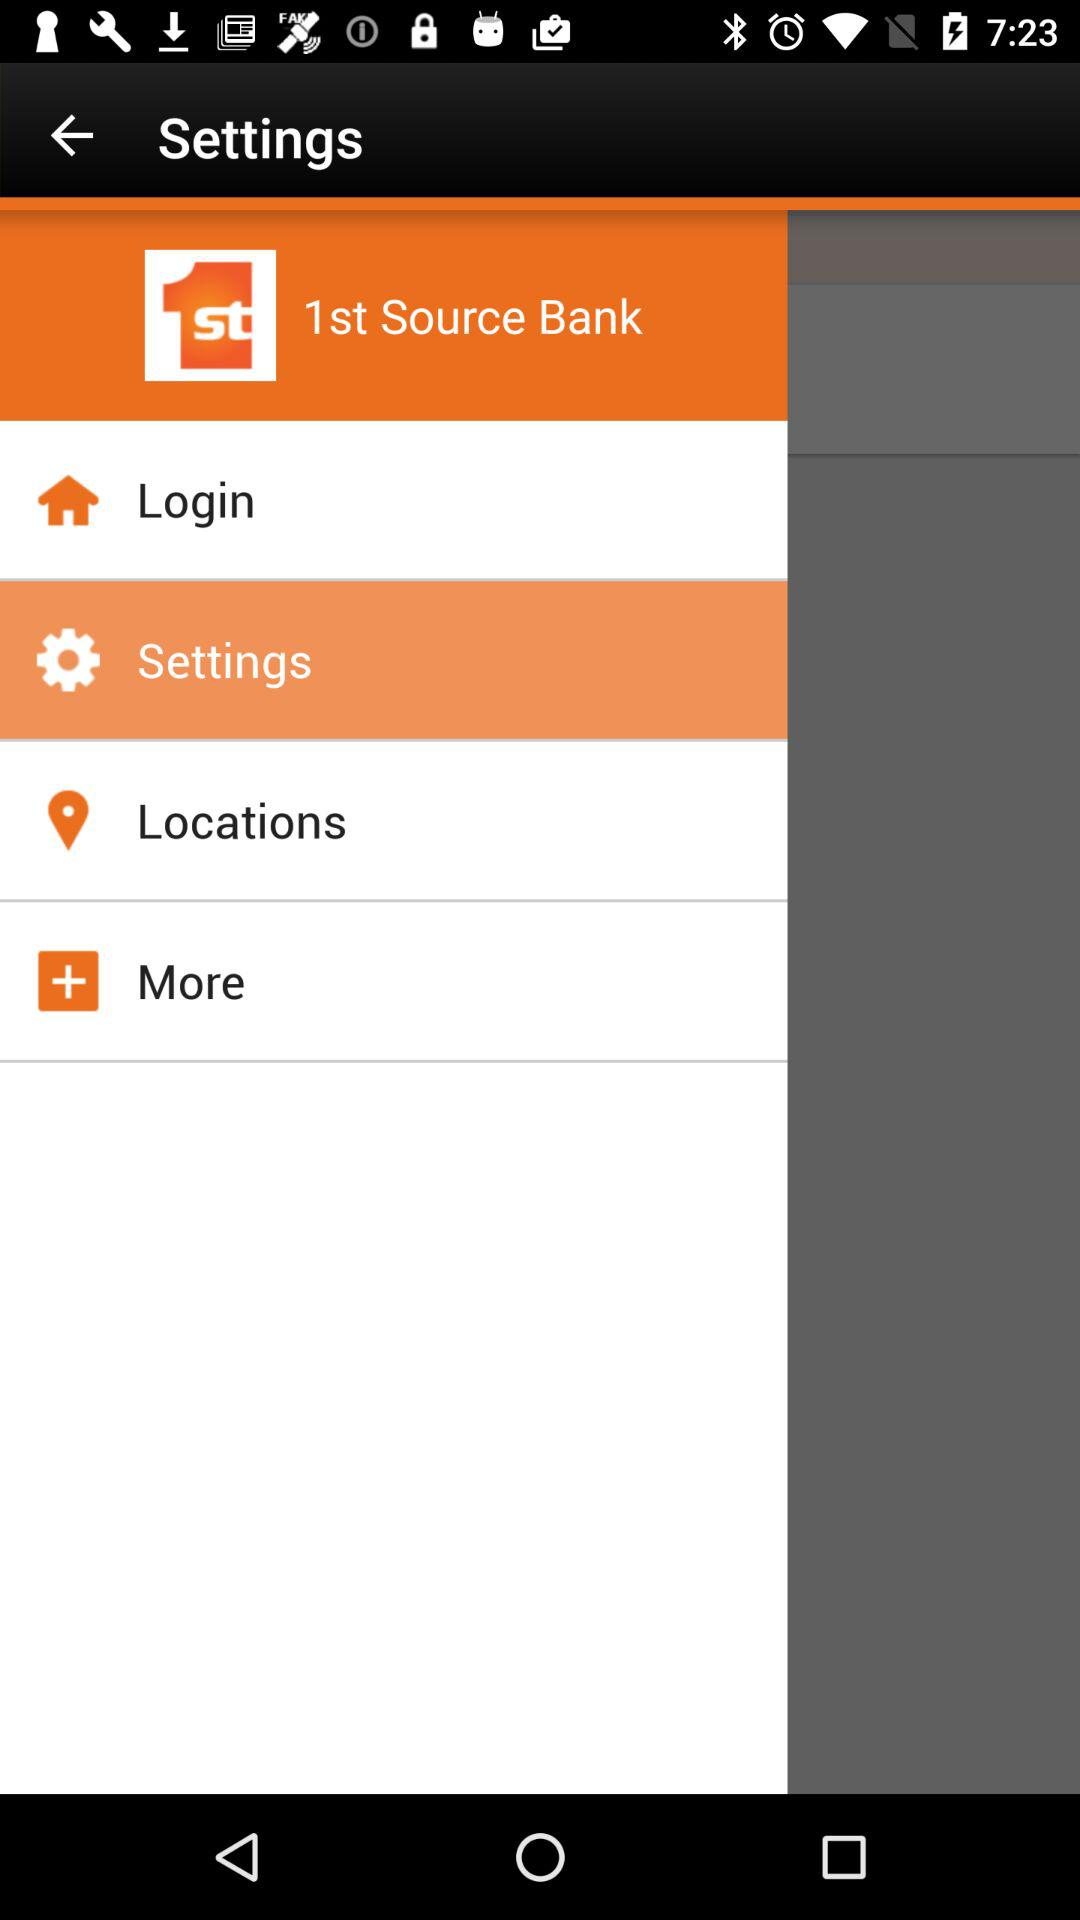What is the application name? The application name is "1st Source Bank". 